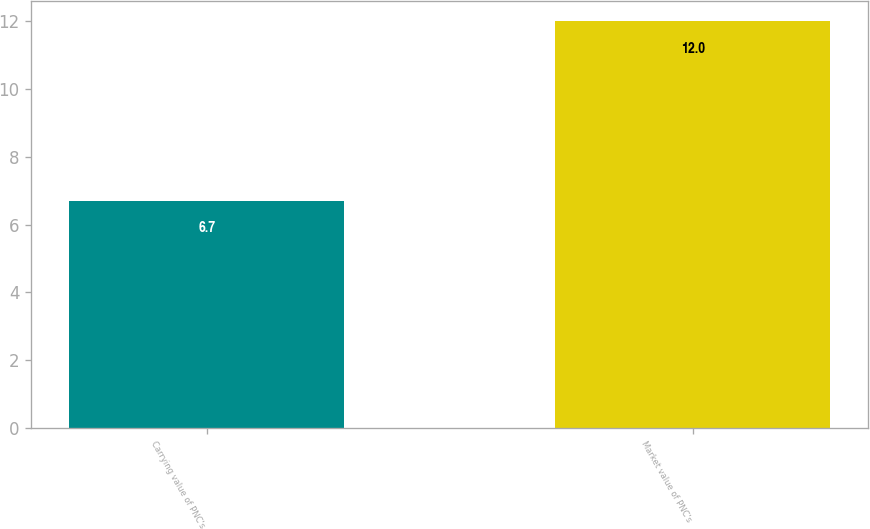Convert chart. <chart><loc_0><loc_0><loc_500><loc_500><bar_chart><fcel>Carrying value of PNC's<fcel>Market value of PNC's<nl><fcel>6.7<fcel>12<nl></chart> 